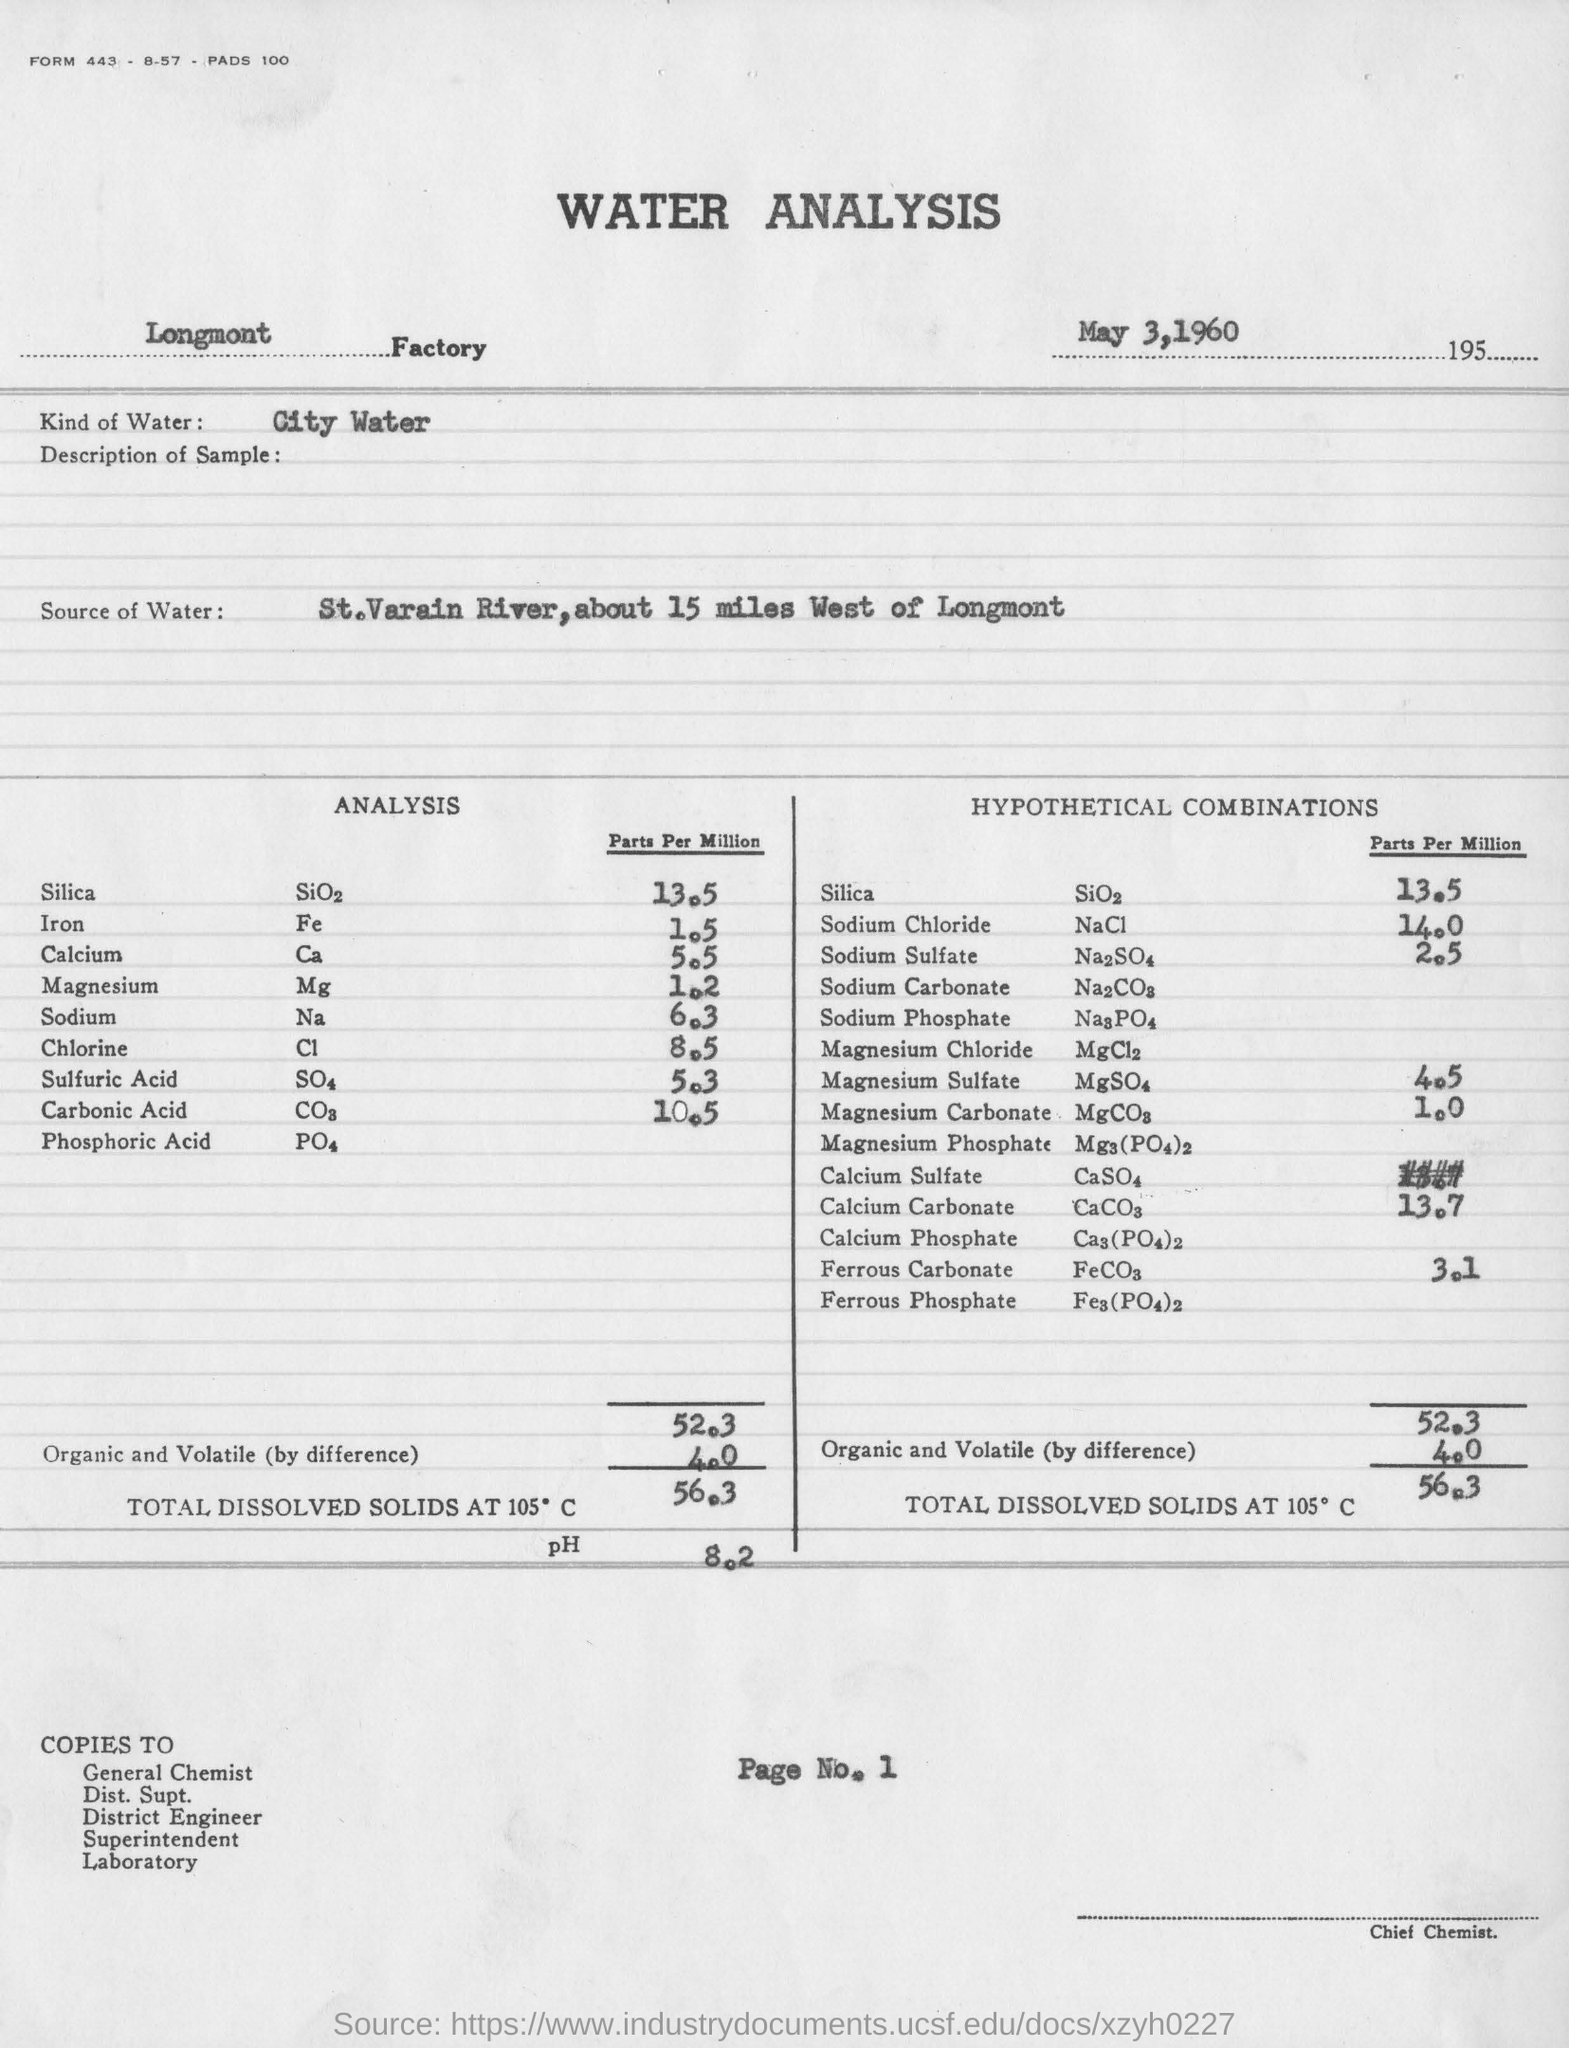What report is this?
Make the answer very short. Water Analysis. What is factory name printed in this report?
Offer a terse response. Longmont factory. What is the date mentioned?
Make the answer very short. May 3,1960. What kind of water is it?
Make the answer very short. City water. What is the source of water?
Provide a short and direct response. St.Varain River,about 15 miles West of Longmont. Which designation mentioned in right bottom corner of the page?
Your response must be concise. Chief Chemist. 